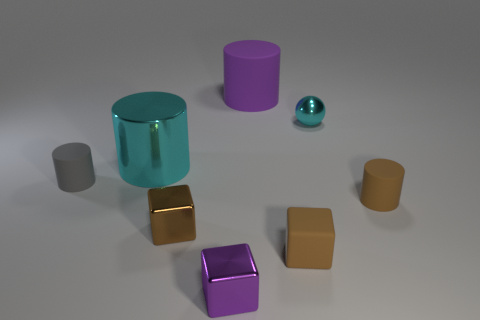Do the objects in this image seem to be randomly placed or is there a pattern to their arrangement? The objects appear to be randomly placed, as there is no discernible pattern or symmetry to their arrangement. Each object occupies its own space without an obvious sequence or organization. 